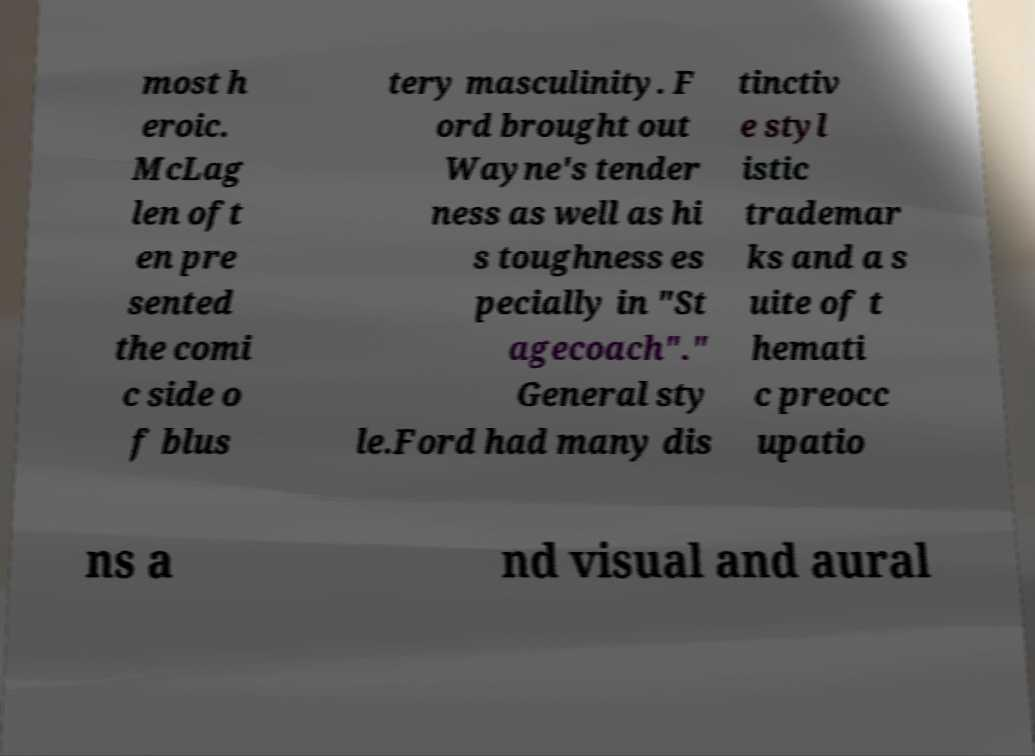What messages or text are displayed in this image? I need them in a readable, typed format. most h eroic. McLag len oft en pre sented the comi c side o f blus tery masculinity. F ord brought out Wayne's tender ness as well as hi s toughness es pecially in "St agecoach"." General sty le.Ford had many dis tinctiv e styl istic trademar ks and a s uite of t hemati c preocc upatio ns a nd visual and aural 